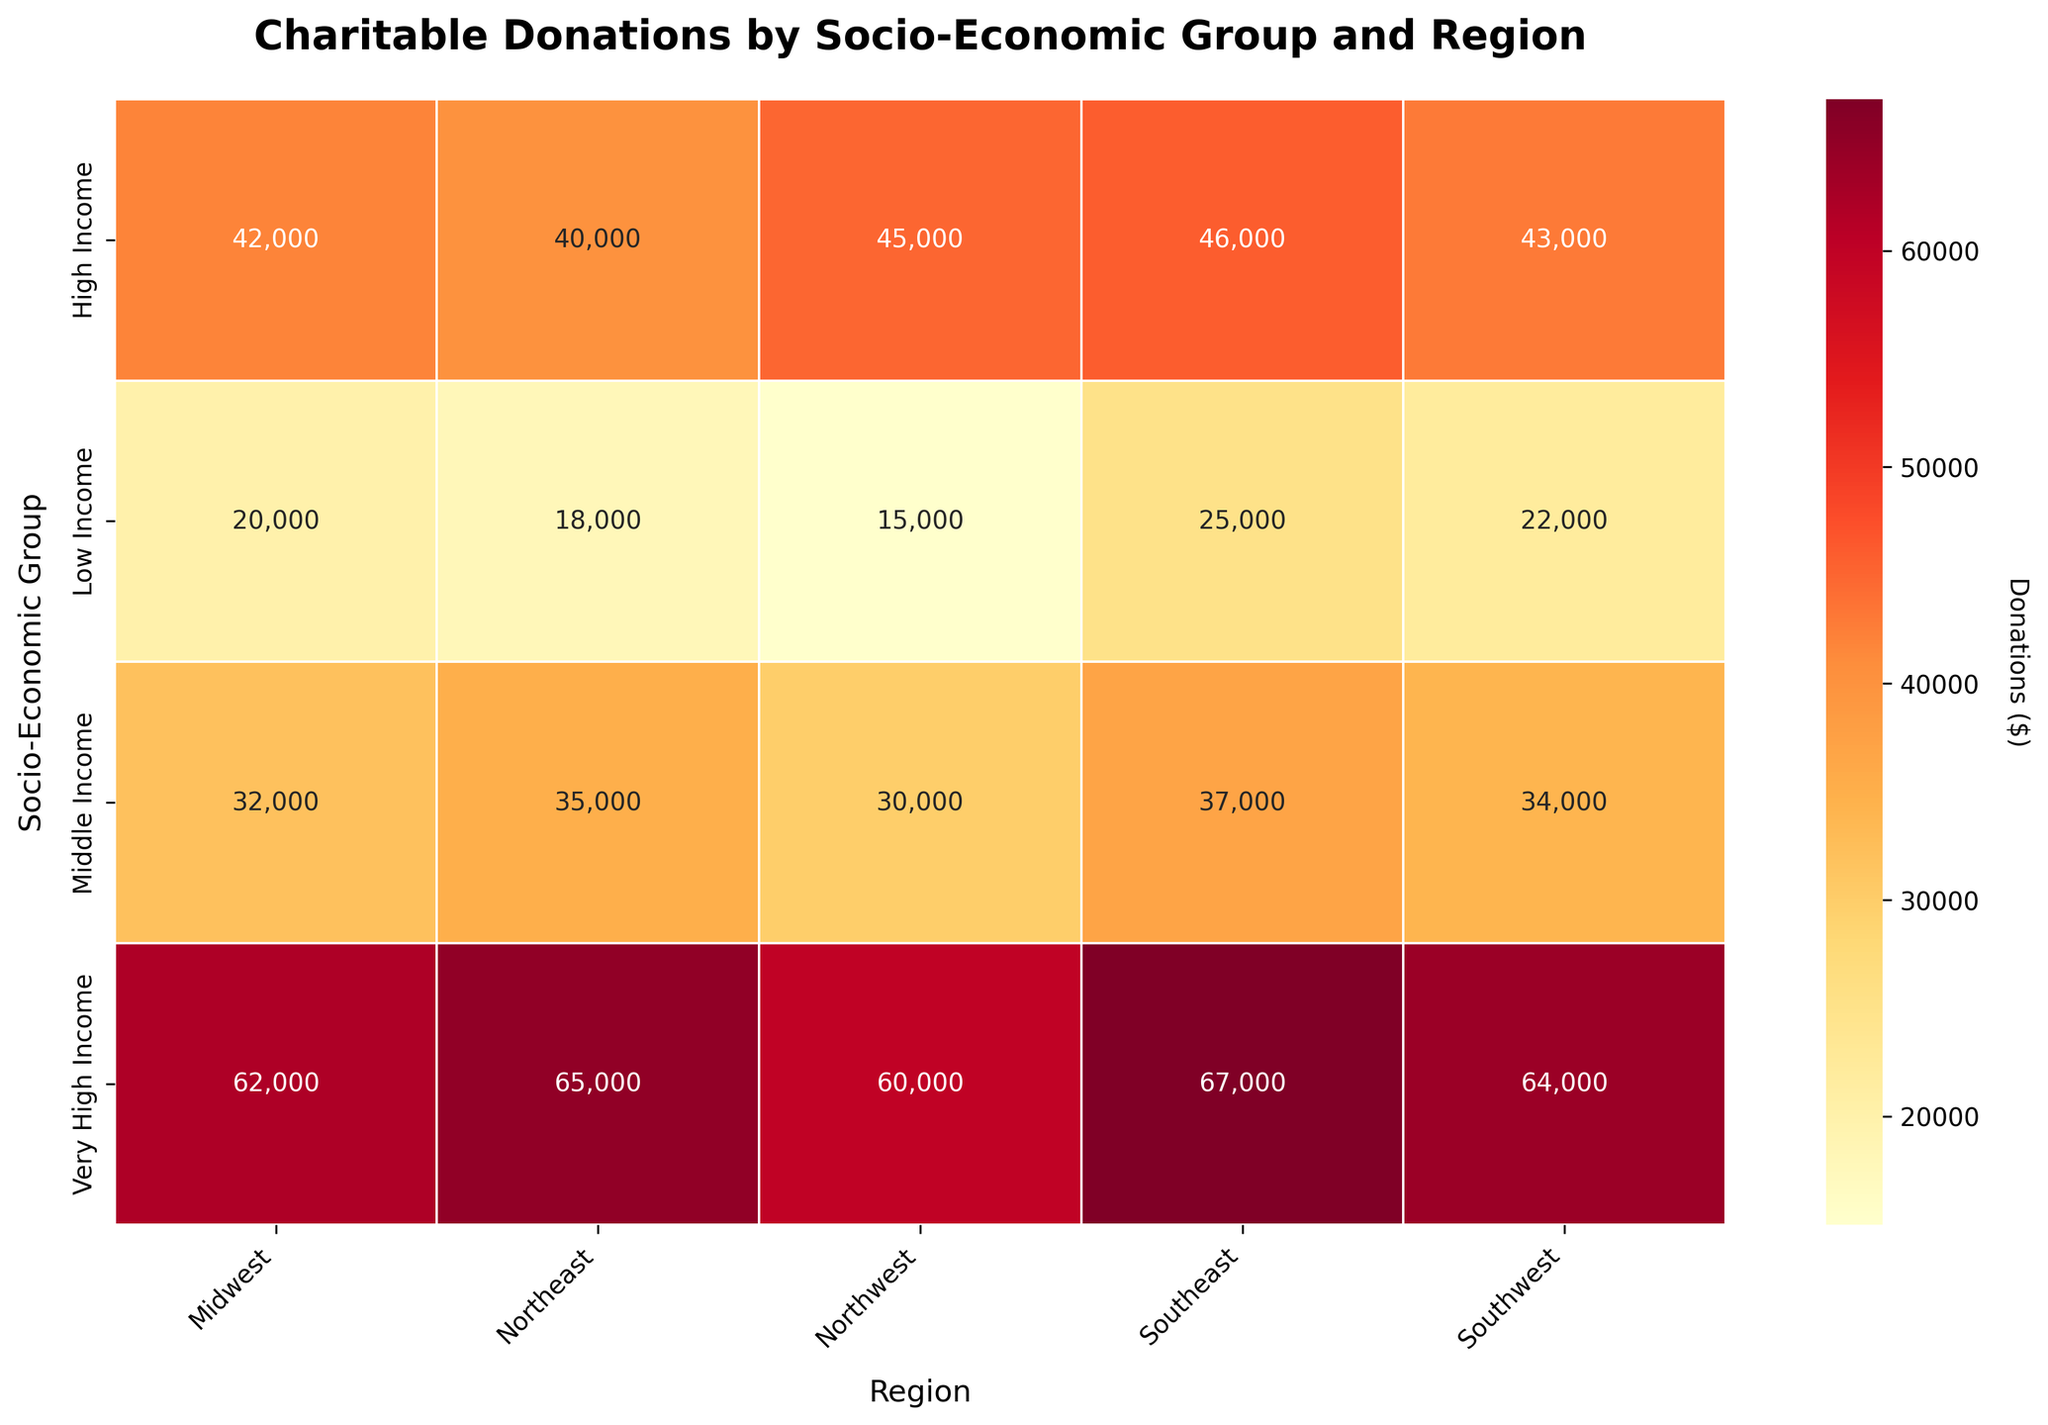how many socio-economic groups are shown in the heatmap? The heatmap displays axes for socio-economic groups labeled on the y-axis. Counting these labels gives us the number of groups represented.
Answer: 4 In which region does the 'Middle Income' group contribute the least in charitable donations? Referring to the 'Middle Income' row in the heatmap, each cell represents an amount in a different region. The region with the smallest number shows the lowest donations.
Answer: Midwest What is the difference in charitable donations between the 'High Income' and 'Low Income' groups in the Southeast region? Locate the cells at the intersection of 'High Income' and Southeast, and 'Low Income' and Southeast. Subtract the value of the 'Low Income' cell from that of the 'High Income' cell.
Answer: 21000 What is the average amount of charitable donations in the Southwest region across all socio-economic groups? Identify the cells in the Southwest column. Sum these values and then divide by the number of socio-economic groups.
Answer: 43000 Which socio-economic group has the highest charitable donations in the Northeast region? Locate the column titled 'Northeast' and identify the cell with the highest value. The corresponding row label gives the socio-economic group.
Answer: Very High Income How do the charitable donations of the 'Very High Income' group in the Northeast compare with the 'Low Income' group in the Northeast? Contrast the values in the cells at the intersection of the 'Very High Income' and 'Low Income' rows with the Northeast column.
Answer: 47,000 higher Do the Middle Income groups donate more in the Northwest or Midwest regions? Examine the Middle Income row and compare the values in the Northwest and Midwest columns.
Answer: Midwest Which region receives the highest average donations from all socio-economic groups? Sum the donations for each region and then divide by the number of groups for each region. Compare these averages to determine the region with the highest average.
Answer: Southeast What is the largest single donation value displayed in the heatmap, and which group and region does it correspond to? Identify the cell with the highest value in the heatmap and note the corresponding row and column labels.
Answer: 67000, Very High Income, Southeast 